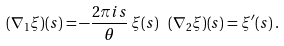<formula> <loc_0><loc_0><loc_500><loc_500>( \nabla _ { 1 } \xi ) ( s ) = - \frac { 2 \pi i s } { \theta } \, \xi ( s ) \ \, ( \nabla _ { 2 } \xi ) ( s ) = \xi ^ { \prime } ( s ) \, .</formula> 